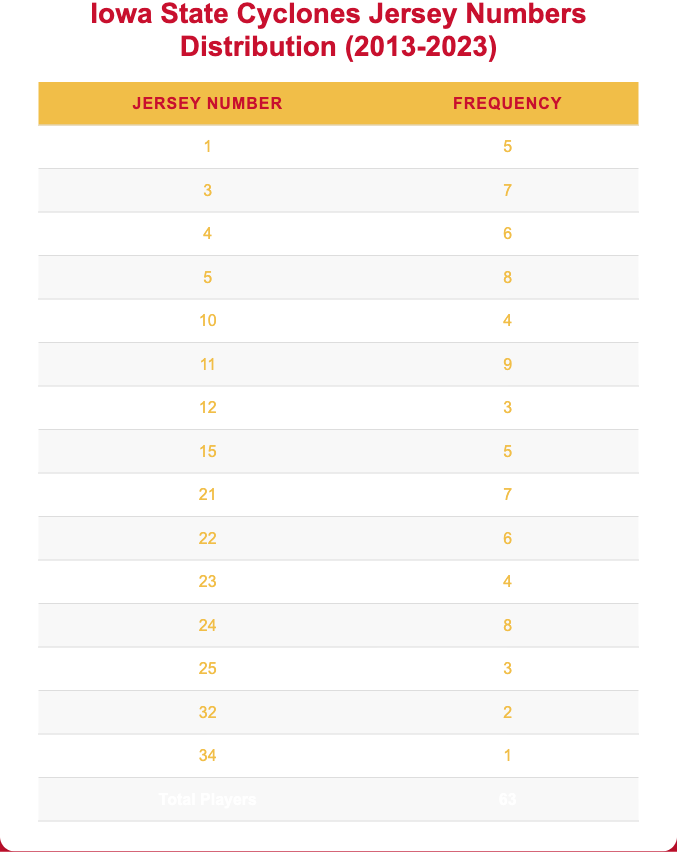What is the jersey number with the highest frequency? The jersey number with the highest frequency can be found by comparing the values in the frequency column. The highest frequency is 9, which corresponds to the jersey number 11.
Answer: 11 How many players wore the jersey number 5? According to the table, the jersey number 5 has a frequency of 8, meaning 8 players wore this number during the last decade.
Answer: 8 What is the total number of players who wore jersey numbers above 20? To find this, we look for jersey numbers above 20 in the table (21, 22, 23, 24, 25, 32, 34) and sum their frequencies: 7 + 6 + 4 + 8 + 3 + 2 + 1 = 31.
Answer: 31 Is there any jersey number that was worn by only one player? Yes, by reviewing the frequencies, we see that the jersey number 34 was worn by only one player.
Answer: Yes What is the average frequency of jersey numbers worn by players? To find the average frequency, we add up all the frequencies: 5 + 7 + 6 + 8 + 4 + 9 + 3 + 5 + 7 + 6 + 4 + 8 + 3 + 2 + 1 = 63. Since there are 15 different jersey numbers, the average is 63 / 15 = 4.2.
Answer: 4.2 What percentage of players wore the jersey number 11? The percentage of players wearing jersey number 11 can be calculated as (frequency of jersey number 11 / total players) * 100% = (9 / 63) * 100% = 14.29%.
Answer: 14.29% How many more players wore jersey number 24 compared to jersey number 1? The number of players who wore jersey number 24 is 8, and for jersey number 1, it is 5. The difference is calculated as 8 - 5 = 3.
Answer: 3 Which jersey number had the least number of players, and how many were they? By examining the frequencies, we find that jersey number 34 had the least number of players, which is 1.
Answer: 34, 1 